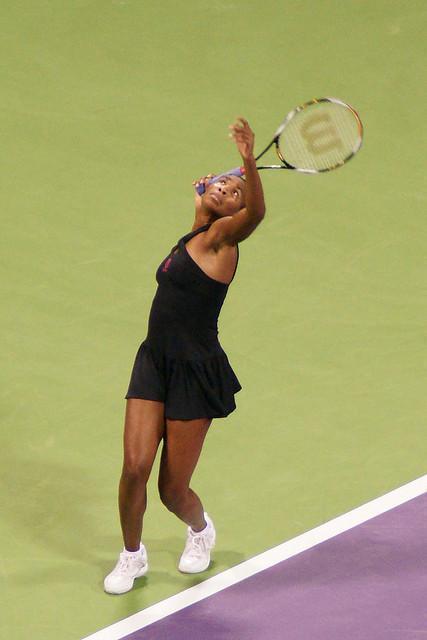How many feet does this person have on the ground?
Give a very brief answer. 2. 